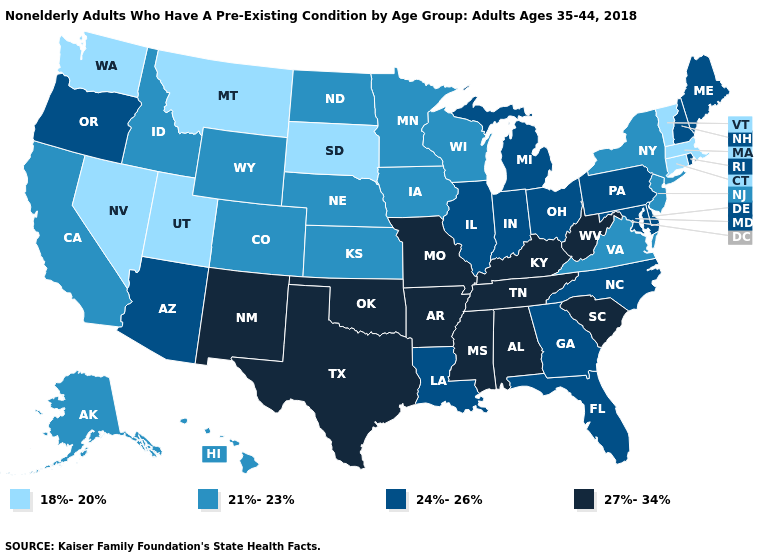Which states have the lowest value in the USA?
Concise answer only. Connecticut, Massachusetts, Montana, Nevada, South Dakota, Utah, Vermont, Washington. Name the states that have a value in the range 27%-34%?
Quick response, please. Alabama, Arkansas, Kentucky, Mississippi, Missouri, New Mexico, Oklahoma, South Carolina, Tennessee, Texas, West Virginia. What is the value of New Jersey?
Give a very brief answer. 21%-23%. Which states have the highest value in the USA?
Short answer required. Alabama, Arkansas, Kentucky, Mississippi, Missouri, New Mexico, Oklahoma, South Carolina, Tennessee, Texas, West Virginia. What is the value of Georgia?
Short answer required. 24%-26%. What is the value of Delaware?
Short answer required. 24%-26%. Name the states that have a value in the range 27%-34%?
Write a very short answer. Alabama, Arkansas, Kentucky, Mississippi, Missouri, New Mexico, Oklahoma, South Carolina, Tennessee, Texas, West Virginia. Does Virginia have the lowest value in the South?
Concise answer only. Yes. Which states have the lowest value in the MidWest?
Write a very short answer. South Dakota. What is the value of Minnesota?
Be succinct. 21%-23%. Does New Hampshire have the lowest value in the USA?
Answer briefly. No. Does Delaware have the same value as Wisconsin?
Concise answer only. No. Which states hav the highest value in the South?
Answer briefly. Alabama, Arkansas, Kentucky, Mississippi, Oklahoma, South Carolina, Tennessee, Texas, West Virginia. Name the states that have a value in the range 27%-34%?
Be succinct. Alabama, Arkansas, Kentucky, Mississippi, Missouri, New Mexico, Oklahoma, South Carolina, Tennessee, Texas, West Virginia. 